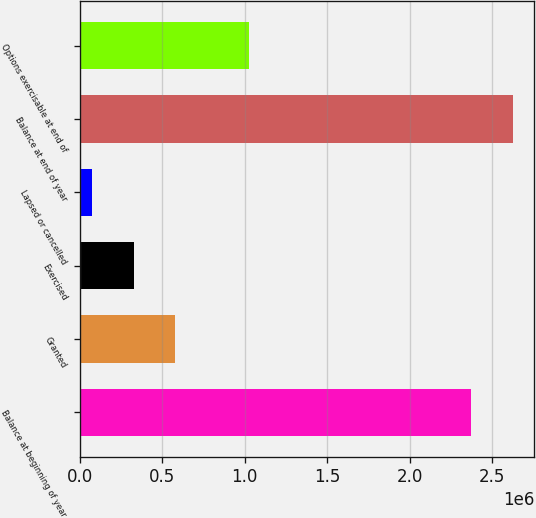Convert chart. <chart><loc_0><loc_0><loc_500><loc_500><bar_chart><fcel>Balance at beginning of year<fcel>Granted<fcel>Exercised<fcel>Lapsed or cancelled<fcel>Balance at end of year<fcel>Options exercisable at end of<nl><fcel>2.37182e+06<fcel>579344<fcel>327004<fcel>74664<fcel>2.62416e+06<fcel>1.02264e+06<nl></chart> 